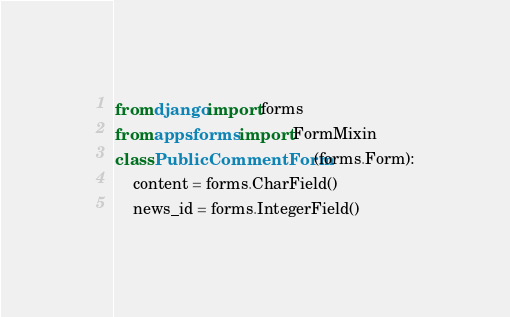Convert code to text. <code><loc_0><loc_0><loc_500><loc_500><_Python_>from django import forms
from apps.forms import FormMixin
class PublicCommentForm(forms.Form):
    content = forms.CharField()
    news_id = forms.IntegerField()
</code> 